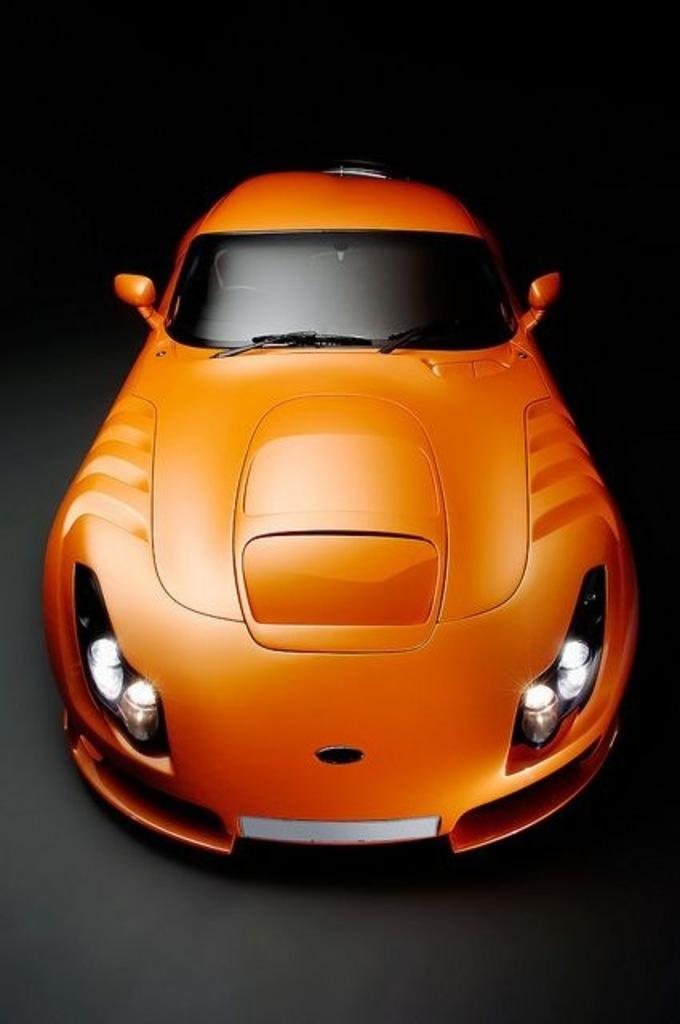What is the main subject of the image? There is a car in the center of the image. How many goldfish are swimming in the car's engine in the image? There are no goldfish present in the image, and therefore no such activity can be observed. 